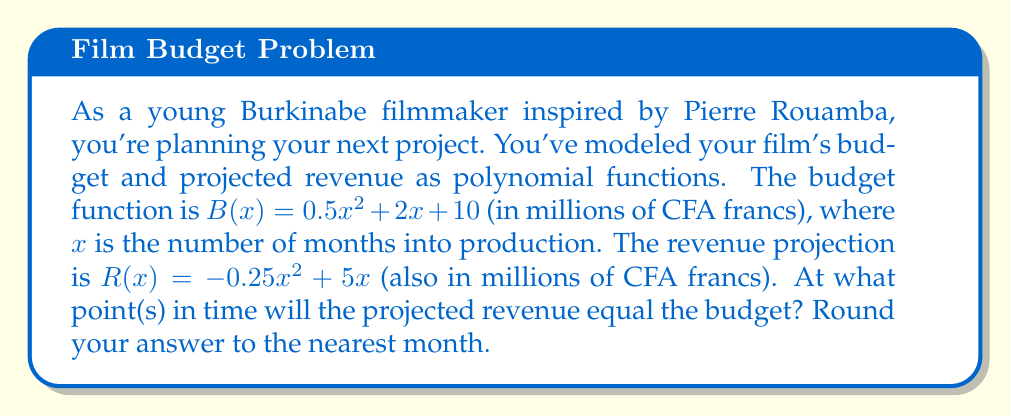Could you help me with this problem? To find the intersection points of these two polynomial curves, we need to solve the equation:

$B(x) = R(x)$

Substituting the given functions:

$0.5x^2 + 2x + 10 = -0.25x^2 + 5x$

Rearranging the equation to standard form:

$0.5x^2 + 2x + 10 + 0.25x^2 - 5x = 0$
$0.75x^2 - 3x + 10 = 0$

This is a quadratic equation in the form $ax^2 + bx + c = 0$, where:
$a = 0.75$
$b = -3$
$c = 10$

We can solve this using the quadratic formula: $x = \frac{-b \pm \sqrt{b^2 - 4ac}}{2a}$

Substituting our values:

$x = \frac{3 \pm \sqrt{(-3)^2 - 4(0.75)(10)}}{2(0.75)}$

$x = \frac{3 \pm \sqrt{9 - 30}}{1.5}$

$x = \frac{3 \pm \sqrt{-21}}{1.5}$

Since the discriminant is negative, there are no real solutions. This means the budget and revenue curves never intersect.

Interpreting this result in the context of filmmaking, it suggests that under the current projections, the revenue never equals the budget. This could indicate that the project may not be financially viable as modeled, and you might need to reconsider your budget or revenue projections.
Answer: There are no intersection points. The budget and revenue curves never meet, indicating that the projected revenue never equals the budget under the given model. 